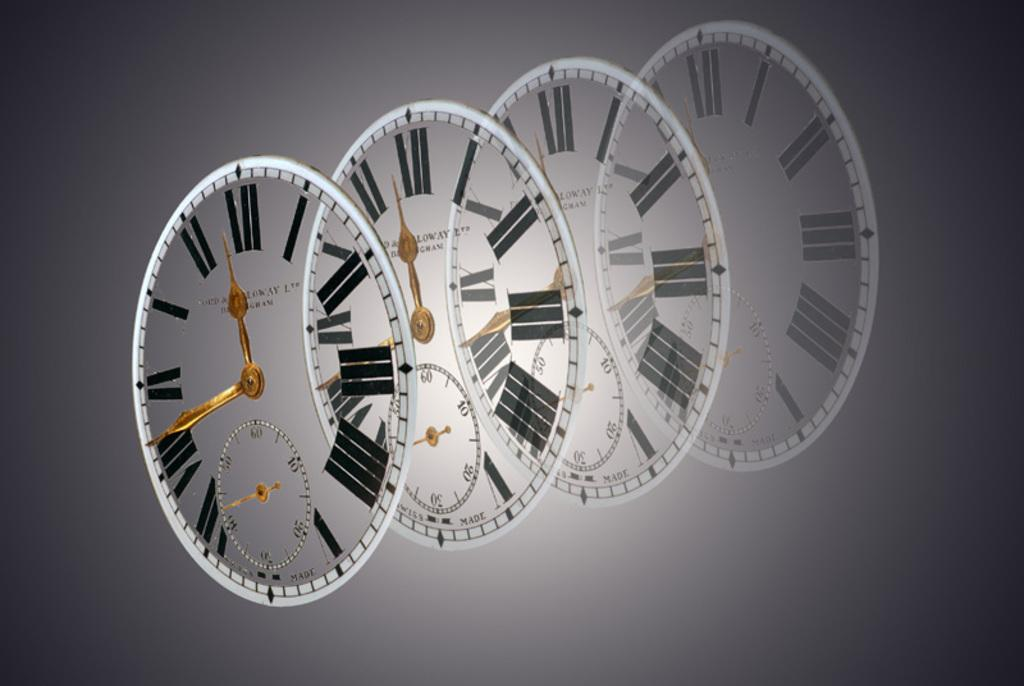<image>
Relay a brief, clear account of the picture shown. A series of clear clock faces display the time as 11:42. 